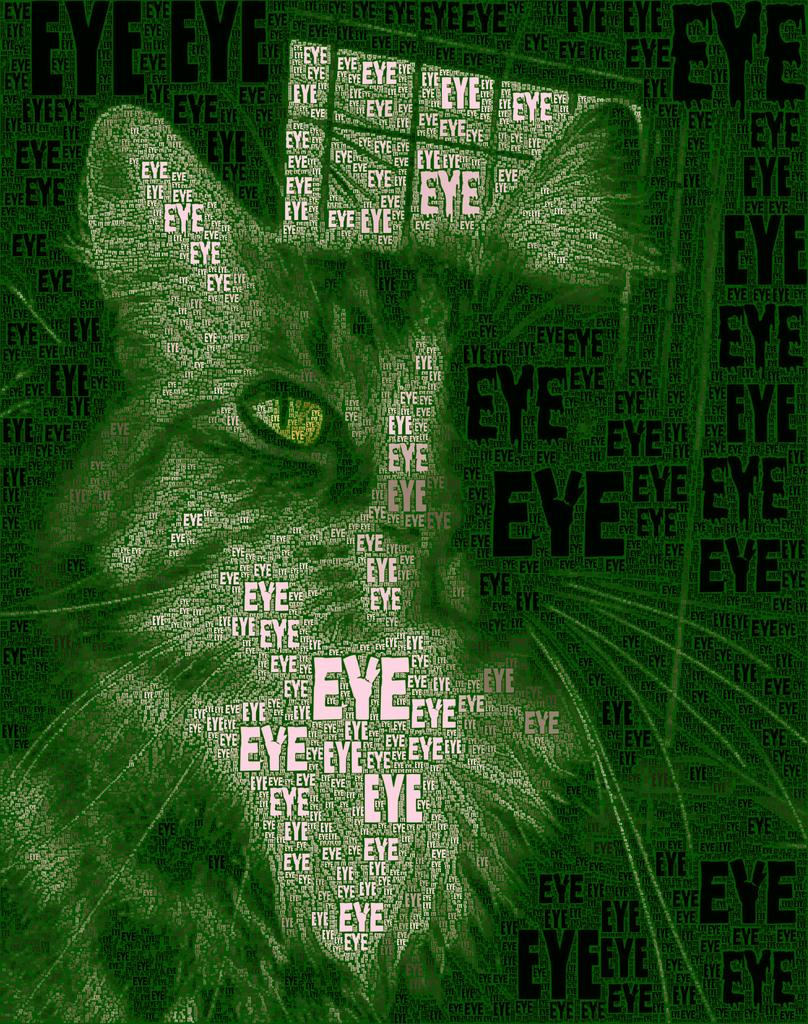What can be found in the image besides the cat? There are words in the image. Can you describe the cat in the image? The image contains an image of a cat. What type of pain is the cat experiencing in the image? There is no indication of pain in the image; the cat appears to be in a normal state. Where is the coat located in the image? There is no coat present in the image. 